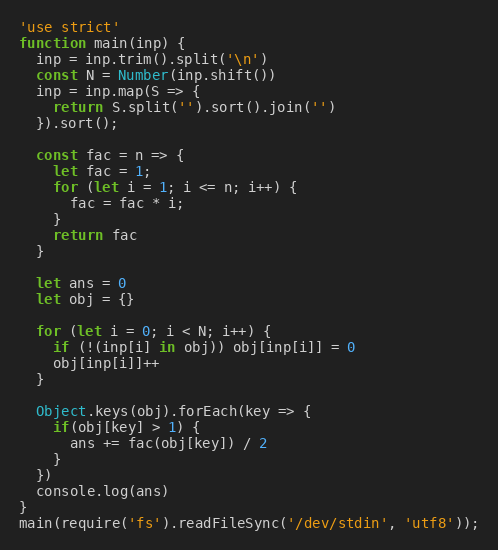<code> <loc_0><loc_0><loc_500><loc_500><_JavaScript_>'use strict'
function main(inp) {
  inp = inp.trim().split('\n')
  const N = Number(inp.shift())
  inp = inp.map(S => {
    return S.split('').sort().join('')
  }).sort();

  const fac = n => {
    let fac = 1;
    for (let i = 1; i <= n; i++) {
      fac = fac * i;
    }
    return fac
  }

  let ans = 0
  let obj = {}

  for (let i = 0; i < N; i++) {
    if (!(inp[i] in obj)) obj[inp[i]] = 0
    obj[inp[i]]++
  }

  Object.keys(obj).forEach(key => {
    if(obj[key] > 1) {
      ans += fac(obj[key]) / 2
    }
  })
  console.log(ans)
}
main(require('fs').readFileSync('/dev/stdin', 'utf8'));
</code> 